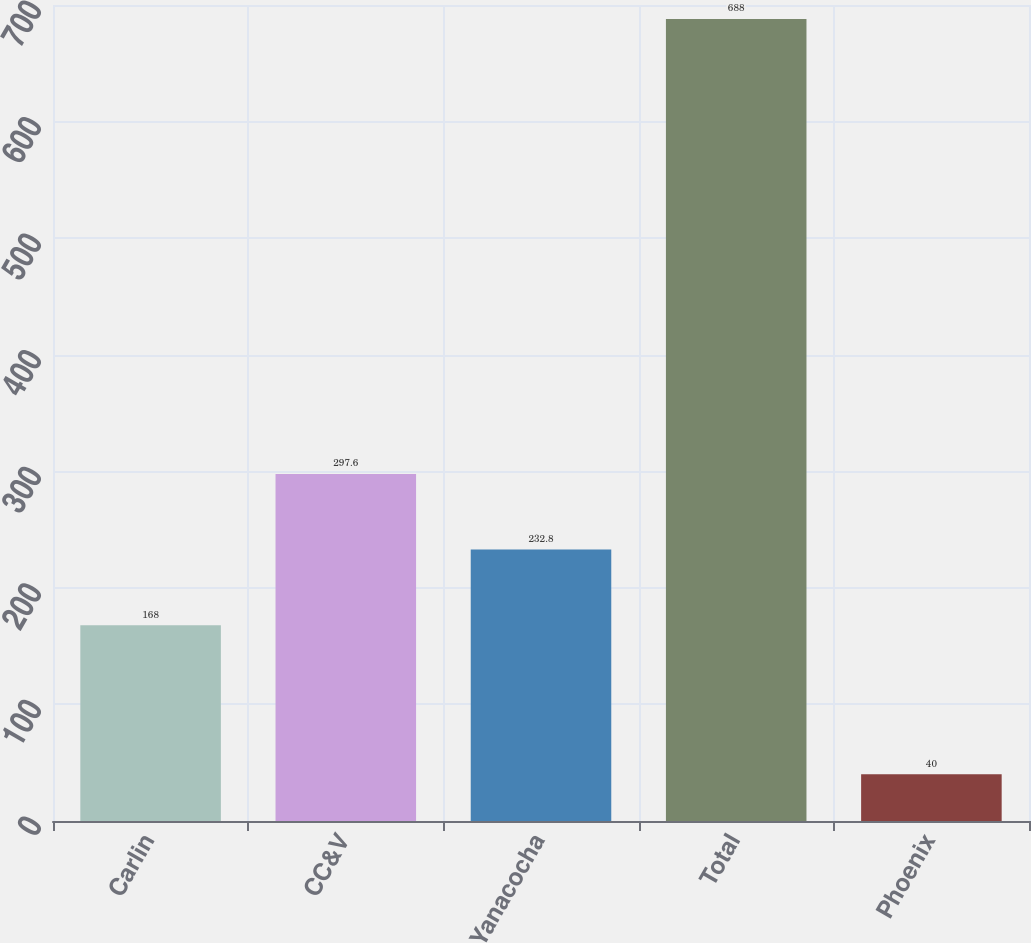Convert chart to OTSL. <chart><loc_0><loc_0><loc_500><loc_500><bar_chart><fcel>Carlin<fcel>CC&V<fcel>Yanacocha<fcel>Total<fcel>Phoenix<nl><fcel>168<fcel>297.6<fcel>232.8<fcel>688<fcel>40<nl></chart> 